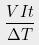<formula> <loc_0><loc_0><loc_500><loc_500>\frac { V I t } { \Delta T }</formula> 